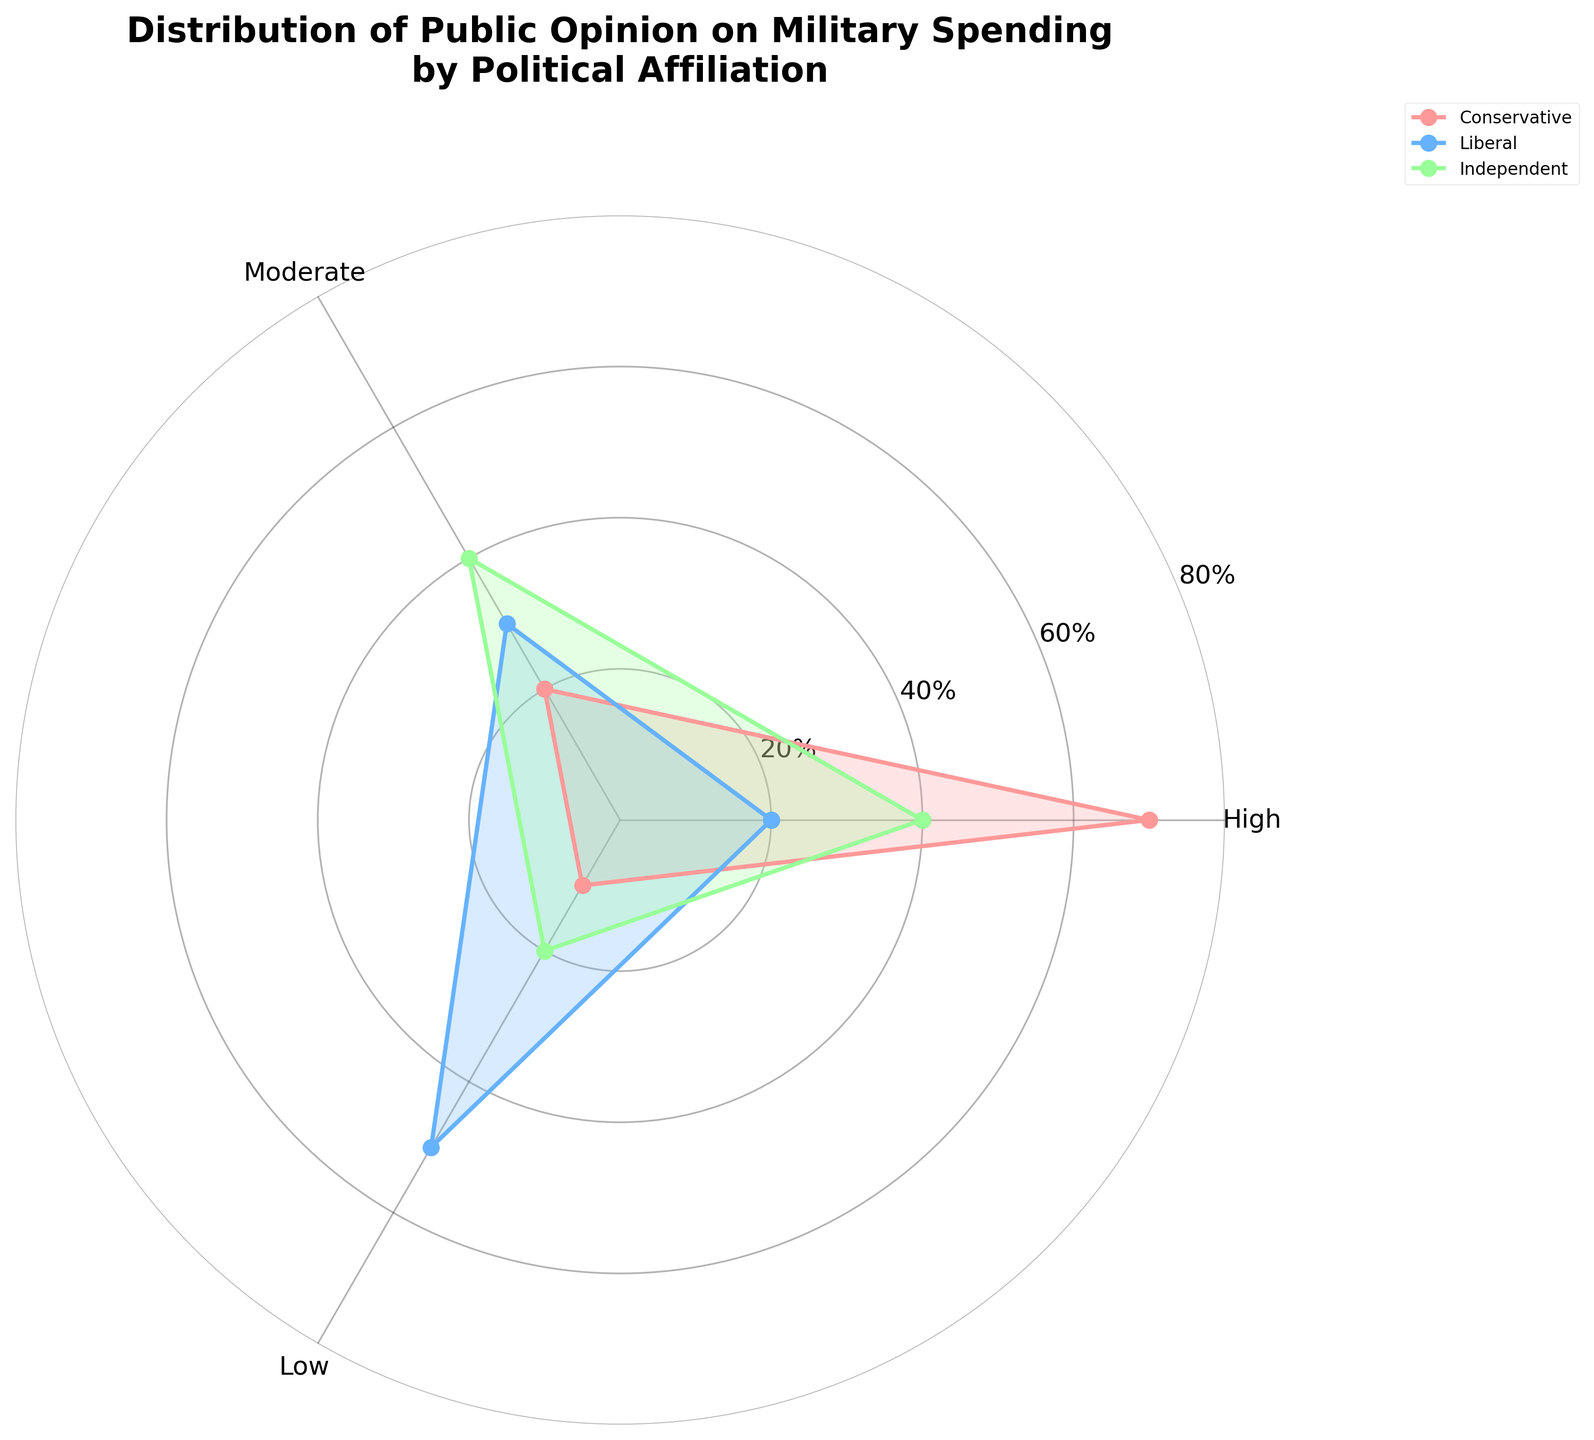What's the title of the figure? The title is typically found at the top of the figure indicating the main topic or purpose of the chart. In this figure, it summarizes what the data is about.
Answer: Distribution of Public Opinion on Military Spending by Political Affiliation How many political affiliations are represented in the figure? The figure shows different lines and fills for each political affiliation. By counting these distinctions, we identify that there are three unique affiliations.
Answer: 3 What percentage of liberals support low military spending? The figure includes data labels or tick marks that indicate percentages. By observing the segment corresponding to liberals, we can check the low spending level.
Answer: 50% Are conservatives more likely to support high military spending than independents? To answer this, compare the percentages of high military spending support for both groups. Conservatives show a higher value compared to independents.
Answer: Yes What's the combined percentage of independents supporting moderate or low spending? Sum the percentages of independents supporting moderate spending and low spending. Refer to the angles for both moderate and low spending. Moderate (40%) + Low (20%) = 60%.
Answer: 60% What is the difference in the percentage supporting high military spending between conservatives and liberals? Subtract the percentage of liberals supporting high spending from the percentage of conservatives supporting high spending. 70% (conservatives) - 20% (liberals) = 50%.
Answer: 50% Which political affiliation has the most diverse opinions on military spending? The range of opinions can be assessed by the spread of percentages across high, moderate, and low spending. Liberals have a wide range from high (20%) to low (50%).
Answer: Liberals Do independents have equal support for high and moderate military spending? Compare the percentages of independents supporting high and moderate spending. Both are given as 40%.
Answer: No, independents have equal support for moderate (40%) and high (40%) What is the maximum percentage of any group supporting moderate military spending? Observe each group's percentage for moderate spending and identify the highest value. Independents and liberals both have the highest at 40%.
Answer: 40% Which group is least likely to support low military spending? Examine the percentages for low spending across all groups and determine the smallest value. Conservatives have the lowest at 10%.
Answer: Conservatives 